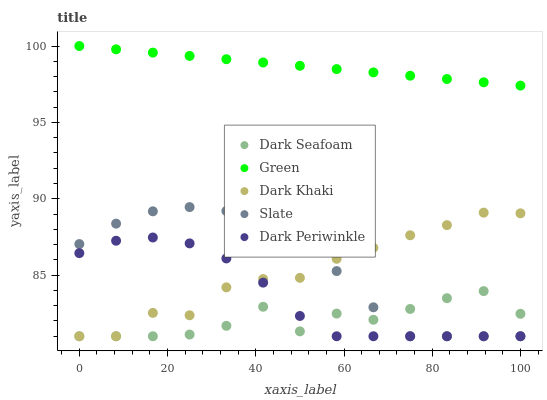Does Dark Seafoam have the minimum area under the curve?
Answer yes or no. Yes. Does Green have the maximum area under the curve?
Answer yes or no. Yes. Does Green have the minimum area under the curve?
Answer yes or no. No. Does Dark Seafoam have the maximum area under the curve?
Answer yes or no. No. Is Green the smoothest?
Answer yes or no. Yes. Is Dark Seafoam the roughest?
Answer yes or no. Yes. Is Dark Seafoam the smoothest?
Answer yes or no. No. Is Green the roughest?
Answer yes or no. No. Does Dark Khaki have the lowest value?
Answer yes or no. Yes. Does Green have the lowest value?
Answer yes or no. No. Does Green have the highest value?
Answer yes or no. Yes. Does Dark Seafoam have the highest value?
Answer yes or no. No. Is Dark Khaki less than Green?
Answer yes or no. Yes. Is Green greater than Dark Periwinkle?
Answer yes or no. Yes. Does Dark Seafoam intersect Dark Periwinkle?
Answer yes or no. Yes. Is Dark Seafoam less than Dark Periwinkle?
Answer yes or no. No. Is Dark Seafoam greater than Dark Periwinkle?
Answer yes or no. No. Does Dark Khaki intersect Green?
Answer yes or no. No. 